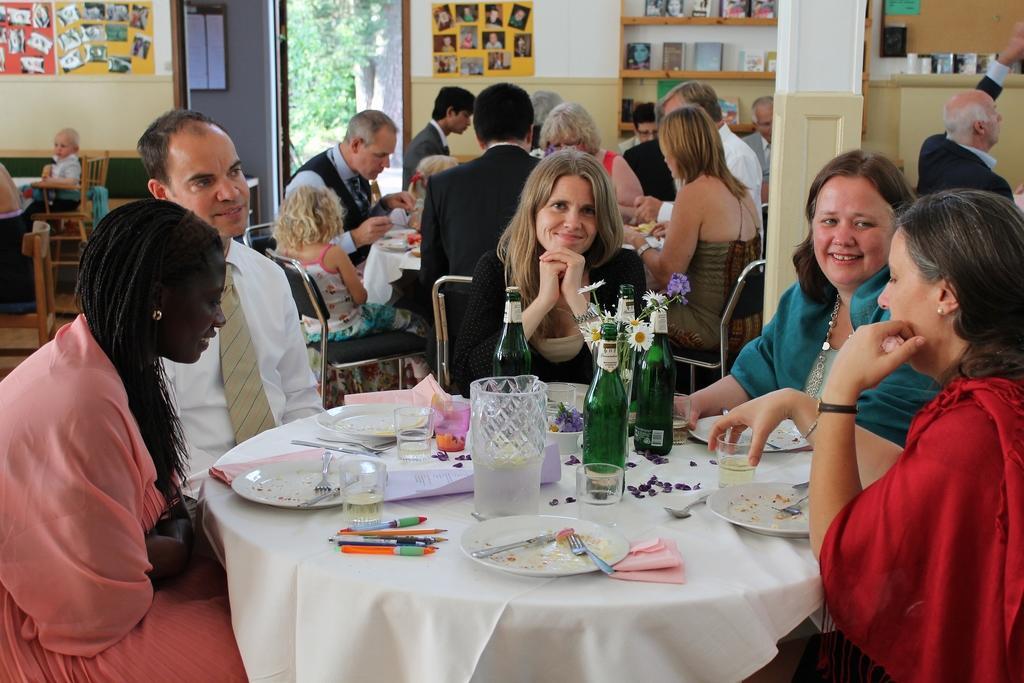Can you describe this image briefly? In this image we can see people are sitting on the chairs around the table. We can see pens, plates, knife, forks, glasses, papers, bottles and flower vase on table. In the background we can see photos on wall. 